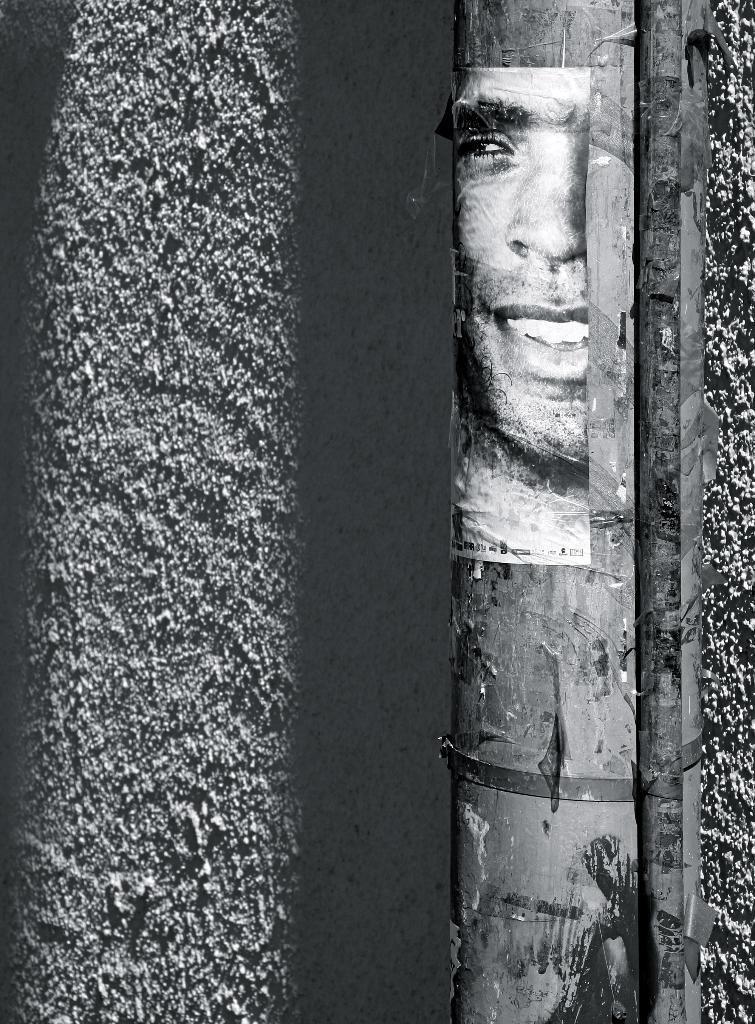What is the color scheme of the image? The image is black and white. What can be seen on the wall in the image? There is a pipe on the wall. What is attached to the pipe? There is a poster of a person smiling on the pipe. What type of scale can be seen on the wall in the image? There is no scale present in the image; it only features a pipe with a poster of a person smiling. 